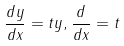Convert formula to latex. <formula><loc_0><loc_0><loc_500><loc_500>\frac { d y } { d x } = t y , \frac { d } { d x } = t</formula> 